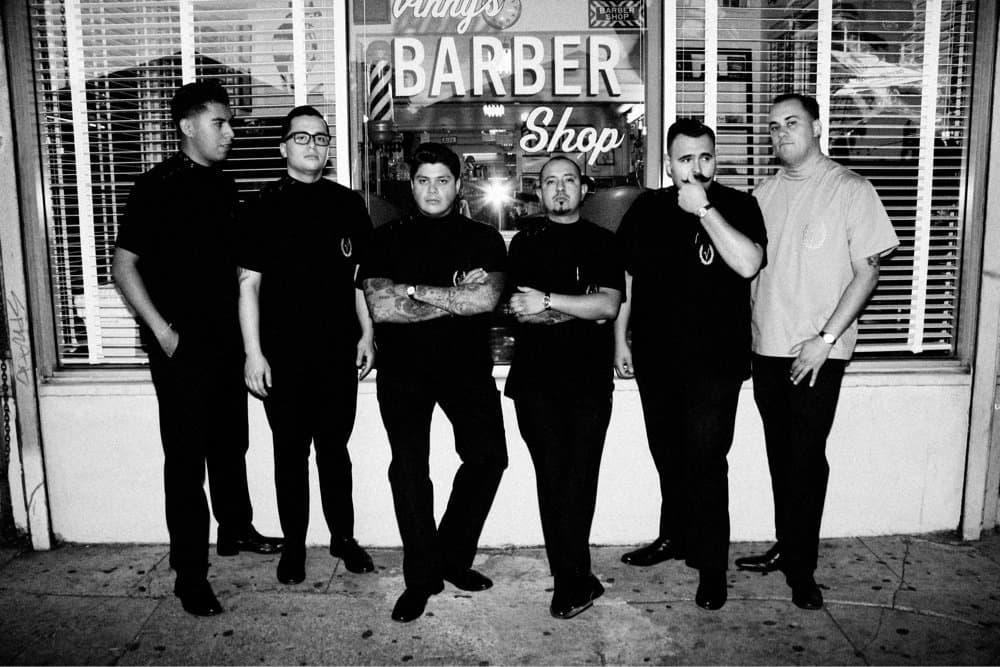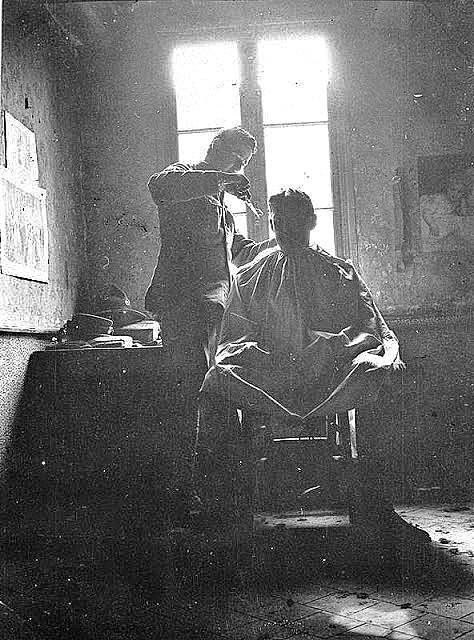The first image is the image on the left, the second image is the image on the right. Examine the images to the left and right. Is the description "The floor of the barbershop in the image on the right has a checkered pattern." accurate? Answer yes or no. No. The first image is the image on the left, the second image is the image on the right. Assess this claim about the two images: "A barbershop in one image has a row of at least four empty barber chairs, with bench seating at the wall behind.". Correct or not? Answer yes or no. No. 